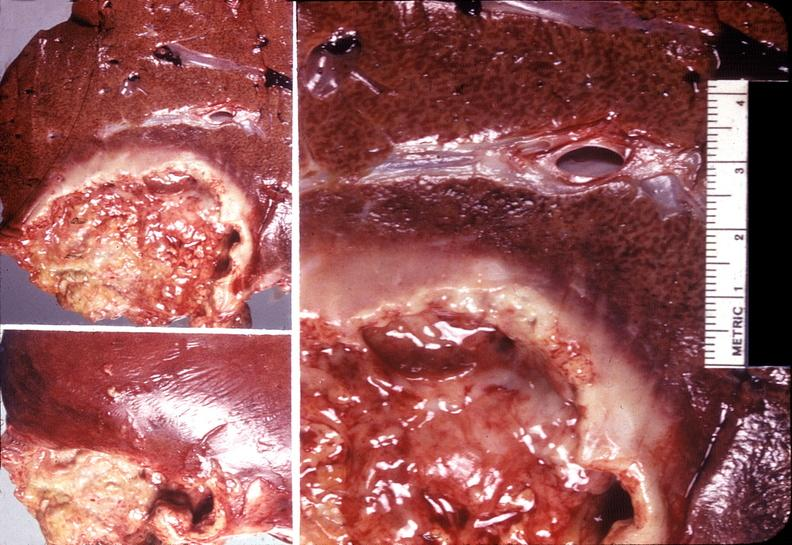s close-up excellent example of interosseous muscle atrophy present?
Answer the question using a single word or phrase. No 